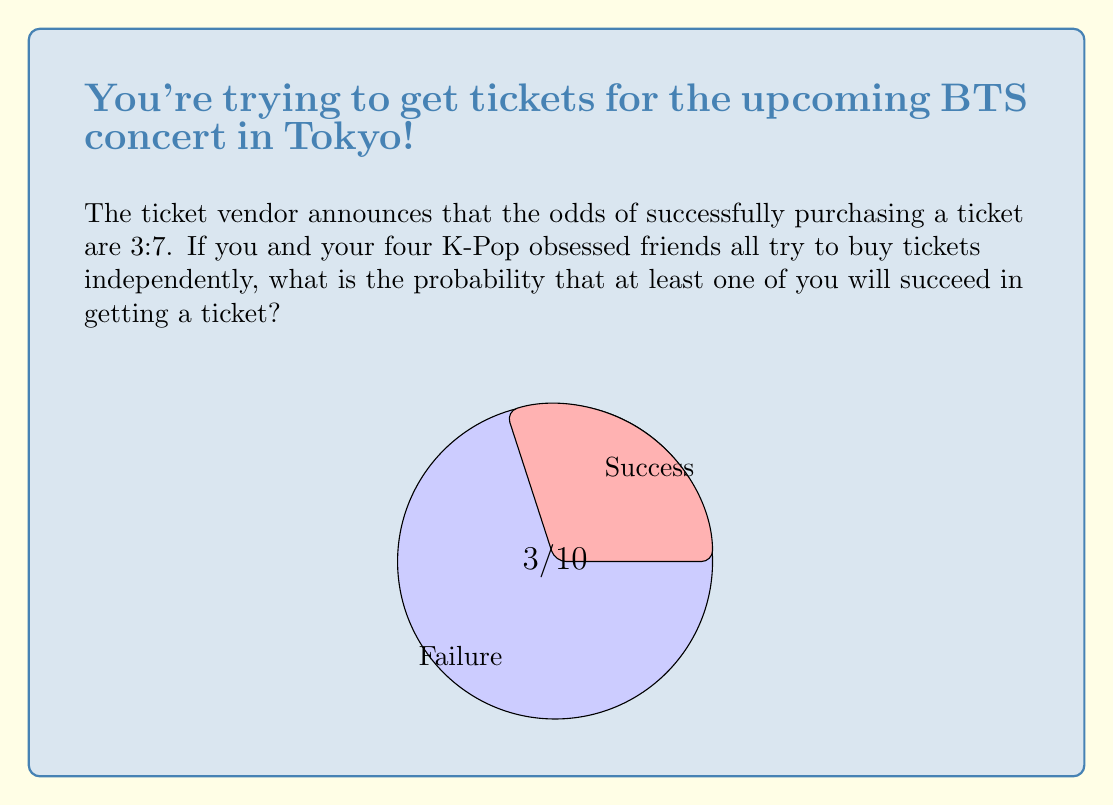What is the answer to this math problem? Let's approach this step-by-step:

1) First, we need to convert the odds to a probability. The odds are 3:7, which means:
   Probability of success = $\frac{3}{3+7} = \frac{3}{10} = 0.3$

2) The probability of not getting a ticket is therefore:
   $1 - 0.3 = 0.7$

3) For at least one person to get a ticket, we can calculate the probability of the opposite event (no one gets a ticket) and subtract it from 1.

4) The probability of no one getting a ticket is:
   $(\frac{7}{10})^5$ (because there are 5 people trying independently)

5) Therefore, the probability of at least one person getting a ticket is:
   $1 - (\frac{7}{10})^5$

6) Let's calculate this:
   $1 - (\frac{7}{10})^5 = 1 - 0.16807 = 0.83193$

7) Converting to a percentage:
   $0.83193 \times 100\% = 83.193\%$
Answer: $83.193\%$ 